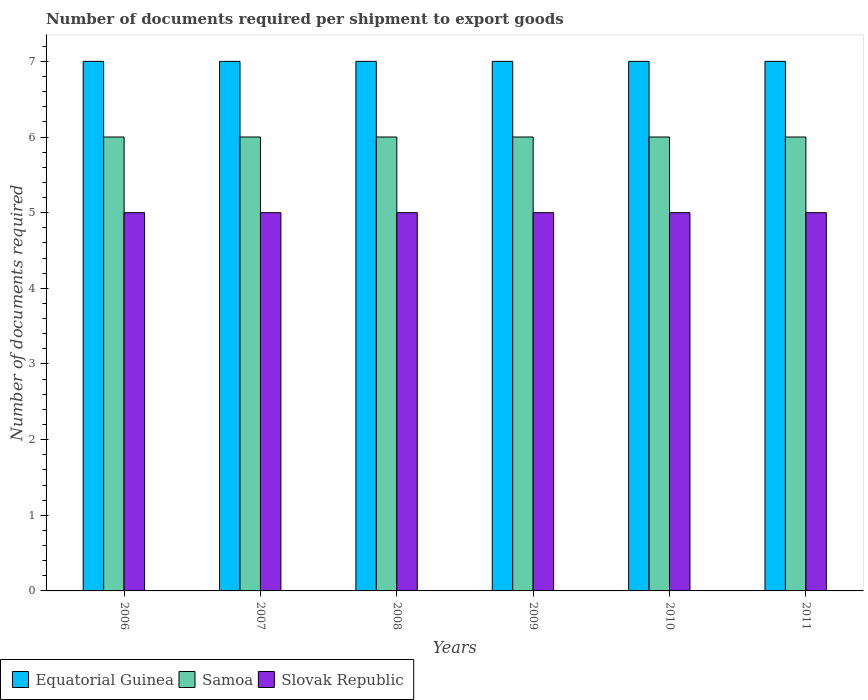How many different coloured bars are there?
Give a very brief answer. 3. How many groups of bars are there?
Your answer should be compact. 6. How many bars are there on the 1st tick from the left?
Offer a terse response. 3. What is the label of the 1st group of bars from the left?
Give a very brief answer. 2006. What is the number of documents required per shipment to export goods in Equatorial Guinea in 2011?
Provide a succinct answer. 7. Across all years, what is the maximum number of documents required per shipment to export goods in Slovak Republic?
Keep it short and to the point. 5. Across all years, what is the minimum number of documents required per shipment to export goods in Slovak Republic?
Your answer should be very brief. 5. In which year was the number of documents required per shipment to export goods in Equatorial Guinea maximum?
Give a very brief answer. 2006. In which year was the number of documents required per shipment to export goods in Equatorial Guinea minimum?
Provide a short and direct response. 2006. What is the total number of documents required per shipment to export goods in Slovak Republic in the graph?
Provide a short and direct response. 30. What is the difference between the number of documents required per shipment to export goods in Samoa in 2007 and that in 2011?
Your answer should be very brief. 0. What is the difference between the number of documents required per shipment to export goods in Samoa in 2011 and the number of documents required per shipment to export goods in Slovak Republic in 2009?
Provide a short and direct response. 1. In the year 2009, what is the difference between the number of documents required per shipment to export goods in Equatorial Guinea and number of documents required per shipment to export goods in Samoa?
Your response must be concise. 1. In how many years, is the number of documents required per shipment to export goods in Equatorial Guinea greater than 1.6?
Ensure brevity in your answer.  6. What is the ratio of the number of documents required per shipment to export goods in Equatorial Guinea in 2007 to that in 2008?
Ensure brevity in your answer.  1. Is the difference between the number of documents required per shipment to export goods in Equatorial Guinea in 2006 and 2007 greater than the difference between the number of documents required per shipment to export goods in Samoa in 2006 and 2007?
Provide a short and direct response. No. In how many years, is the number of documents required per shipment to export goods in Samoa greater than the average number of documents required per shipment to export goods in Samoa taken over all years?
Your answer should be compact. 0. Is the sum of the number of documents required per shipment to export goods in Equatorial Guinea in 2006 and 2011 greater than the maximum number of documents required per shipment to export goods in Slovak Republic across all years?
Keep it short and to the point. Yes. What does the 2nd bar from the left in 2008 represents?
Your answer should be very brief. Samoa. What does the 2nd bar from the right in 2007 represents?
Give a very brief answer. Samoa. Is it the case that in every year, the sum of the number of documents required per shipment to export goods in Equatorial Guinea and number of documents required per shipment to export goods in Slovak Republic is greater than the number of documents required per shipment to export goods in Samoa?
Your response must be concise. Yes. Are all the bars in the graph horizontal?
Your answer should be very brief. No. How many years are there in the graph?
Provide a succinct answer. 6. Are the values on the major ticks of Y-axis written in scientific E-notation?
Ensure brevity in your answer.  No. Does the graph contain grids?
Provide a short and direct response. No. What is the title of the graph?
Offer a terse response. Number of documents required per shipment to export goods. Does "Least developed countries" appear as one of the legend labels in the graph?
Make the answer very short. No. What is the label or title of the Y-axis?
Keep it short and to the point. Number of documents required. What is the Number of documents required of Samoa in 2006?
Your answer should be very brief. 6. What is the Number of documents required in Slovak Republic in 2006?
Give a very brief answer. 5. What is the Number of documents required of Samoa in 2007?
Ensure brevity in your answer.  6. What is the Number of documents required of Slovak Republic in 2007?
Provide a short and direct response. 5. What is the Number of documents required in Slovak Republic in 2008?
Ensure brevity in your answer.  5. What is the Number of documents required of Equatorial Guinea in 2009?
Give a very brief answer. 7. What is the Number of documents required of Samoa in 2009?
Offer a very short reply. 6. What is the Number of documents required in Slovak Republic in 2009?
Offer a terse response. 5. What is the Number of documents required of Equatorial Guinea in 2010?
Give a very brief answer. 7. What is the Number of documents required in Samoa in 2010?
Offer a terse response. 6. What is the Number of documents required of Slovak Republic in 2010?
Provide a succinct answer. 5. What is the Number of documents required of Equatorial Guinea in 2011?
Provide a short and direct response. 7. What is the Number of documents required in Samoa in 2011?
Offer a terse response. 6. What is the Number of documents required of Slovak Republic in 2011?
Make the answer very short. 5. Across all years, what is the minimum Number of documents required of Equatorial Guinea?
Your answer should be very brief. 7. Across all years, what is the minimum Number of documents required of Samoa?
Offer a terse response. 6. What is the difference between the Number of documents required of Slovak Republic in 2006 and that in 2007?
Your answer should be compact. 0. What is the difference between the Number of documents required in Slovak Republic in 2006 and that in 2008?
Keep it short and to the point. 0. What is the difference between the Number of documents required of Samoa in 2006 and that in 2009?
Ensure brevity in your answer.  0. What is the difference between the Number of documents required of Equatorial Guinea in 2006 and that in 2010?
Make the answer very short. 0. What is the difference between the Number of documents required of Samoa in 2006 and that in 2010?
Ensure brevity in your answer.  0. What is the difference between the Number of documents required in Samoa in 2006 and that in 2011?
Keep it short and to the point. 0. What is the difference between the Number of documents required in Equatorial Guinea in 2007 and that in 2008?
Make the answer very short. 0. What is the difference between the Number of documents required of Equatorial Guinea in 2007 and that in 2009?
Your response must be concise. 0. What is the difference between the Number of documents required in Equatorial Guinea in 2007 and that in 2010?
Provide a short and direct response. 0. What is the difference between the Number of documents required in Equatorial Guinea in 2007 and that in 2011?
Offer a terse response. 0. What is the difference between the Number of documents required in Samoa in 2007 and that in 2011?
Give a very brief answer. 0. What is the difference between the Number of documents required of Equatorial Guinea in 2008 and that in 2009?
Make the answer very short. 0. What is the difference between the Number of documents required of Slovak Republic in 2008 and that in 2009?
Provide a short and direct response. 0. What is the difference between the Number of documents required of Samoa in 2008 and that in 2010?
Make the answer very short. 0. What is the difference between the Number of documents required of Slovak Republic in 2008 and that in 2010?
Provide a succinct answer. 0. What is the difference between the Number of documents required of Slovak Republic in 2009 and that in 2010?
Provide a succinct answer. 0. What is the difference between the Number of documents required in Samoa in 2009 and that in 2011?
Provide a short and direct response. 0. What is the difference between the Number of documents required of Equatorial Guinea in 2010 and that in 2011?
Keep it short and to the point. 0. What is the difference between the Number of documents required in Samoa in 2010 and that in 2011?
Offer a very short reply. 0. What is the difference between the Number of documents required in Slovak Republic in 2010 and that in 2011?
Offer a terse response. 0. What is the difference between the Number of documents required in Equatorial Guinea in 2006 and the Number of documents required in Samoa in 2007?
Make the answer very short. 1. What is the difference between the Number of documents required of Equatorial Guinea in 2006 and the Number of documents required of Slovak Republic in 2007?
Provide a short and direct response. 2. What is the difference between the Number of documents required of Samoa in 2006 and the Number of documents required of Slovak Republic in 2007?
Your answer should be compact. 1. What is the difference between the Number of documents required of Equatorial Guinea in 2006 and the Number of documents required of Samoa in 2008?
Your answer should be compact. 1. What is the difference between the Number of documents required of Equatorial Guinea in 2006 and the Number of documents required of Slovak Republic in 2008?
Provide a short and direct response. 2. What is the difference between the Number of documents required in Samoa in 2006 and the Number of documents required in Slovak Republic in 2009?
Offer a very short reply. 1. What is the difference between the Number of documents required in Equatorial Guinea in 2006 and the Number of documents required in Slovak Republic in 2010?
Give a very brief answer. 2. What is the difference between the Number of documents required in Samoa in 2006 and the Number of documents required in Slovak Republic in 2010?
Make the answer very short. 1. What is the difference between the Number of documents required of Equatorial Guinea in 2006 and the Number of documents required of Slovak Republic in 2011?
Provide a succinct answer. 2. What is the difference between the Number of documents required in Equatorial Guinea in 2007 and the Number of documents required in Slovak Republic in 2008?
Give a very brief answer. 2. What is the difference between the Number of documents required in Samoa in 2007 and the Number of documents required in Slovak Republic in 2009?
Your answer should be very brief. 1. What is the difference between the Number of documents required in Equatorial Guinea in 2007 and the Number of documents required in Samoa in 2010?
Offer a terse response. 1. What is the difference between the Number of documents required of Samoa in 2007 and the Number of documents required of Slovak Republic in 2010?
Give a very brief answer. 1. What is the difference between the Number of documents required in Equatorial Guinea in 2007 and the Number of documents required in Samoa in 2011?
Ensure brevity in your answer.  1. What is the difference between the Number of documents required in Equatorial Guinea in 2007 and the Number of documents required in Slovak Republic in 2011?
Keep it short and to the point. 2. What is the difference between the Number of documents required in Samoa in 2007 and the Number of documents required in Slovak Republic in 2011?
Your response must be concise. 1. What is the difference between the Number of documents required of Equatorial Guinea in 2008 and the Number of documents required of Samoa in 2009?
Your answer should be compact. 1. What is the difference between the Number of documents required of Equatorial Guinea in 2008 and the Number of documents required of Slovak Republic in 2009?
Your answer should be very brief. 2. What is the difference between the Number of documents required of Samoa in 2008 and the Number of documents required of Slovak Republic in 2009?
Your answer should be very brief. 1. What is the difference between the Number of documents required in Samoa in 2008 and the Number of documents required in Slovak Republic in 2010?
Keep it short and to the point. 1. What is the difference between the Number of documents required in Equatorial Guinea in 2008 and the Number of documents required in Samoa in 2011?
Provide a succinct answer. 1. What is the difference between the Number of documents required in Equatorial Guinea in 2008 and the Number of documents required in Slovak Republic in 2011?
Keep it short and to the point. 2. What is the difference between the Number of documents required of Equatorial Guinea in 2009 and the Number of documents required of Samoa in 2010?
Make the answer very short. 1. What is the difference between the Number of documents required in Equatorial Guinea in 2009 and the Number of documents required in Slovak Republic in 2010?
Provide a short and direct response. 2. What is the difference between the Number of documents required of Samoa in 2009 and the Number of documents required of Slovak Republic in 2010?
Your answer should be compact. 1. What is the difference between the Number of documents required of Equatorial Guinea in 2009 and the Number of documents required of Samoa in 2011?
Make the answer very short. 1. What is the difference between the Number of documents required in Samoa in 2009 and the Number of documents required in Slovak Republic in 2011?
Offer a terse response. 1. What is the difference between the Number of documents required of Equatorial Guinea in 2010 and the Number of documents required of Samoa in 2011?
Your answer should be very brief. 1. What is the average Number of documents required in Samoa per year?
Offer a terse response. 6. In the year 2006, what is the difference between the Number of documents required in Equatorial Guinea and Number of documents required in Samoa?
Make the answer very short. 1. In the year 2007, what is the difference between the Number of documents required of Equatorial Guinea and Number of documents required of Samoa?
Ensure brevity in your answer.  1. In the year 2007, what is the difference between the Number of documents required of Samoa and Number of documents required of Slovak Republic?
Keep it short and to the point. 1. In the year 2009, what is the difference between the Number of documents required in Equatorial Guinea and Number of documents required in Slovak Republic?
Offer a terse response. 2. In the year 2009, what is the difference between the Number of documents required of Samoa and Number of documents required of Slovak Republic?
Offer a very short reply. 1. In the year 2010, what is the difference between the Number of documents required in Equatorial Guinea and Number of documents required in Samoa?
Provide a succinct answer. 1. In the year 2010, what is the difference between the Number of documents required in Samoa and Number of documents required in Slovak Republic?
Give a very brief answer. 1. In the year 2011, what is the difference between the Number of documents required of Equatorial Guinea and Number of documents required of Samoa?
Provide a short and direct response. 1. In the year 2011, what is the difference between the Number of documents required in Equatorial Guinea and Number of documents required in Slovak Republic?
Make the answer very short. 2. What is the ratio of the Number of documents required in Equatorial Guinea in 2006 to that in 2007?
Offer a terse response. 1. What is the ratio of the Number of documents required of Samoa in 2006 to that in 2007?
Provide a short and direct response. 1. What is the ratio of the Number of documents required of Equatorial Guinea in 2006 to that in 2008?
Your response must be concise. 1. What is the ratio of the Number of documents required in Equatorial Guinea in 2006 to that in 2009?
Provide a succinct answer. 1. What is the ratio of the Number of documents required in Samoa in 2006 to that in 2009?
Provide a short and direct response. 1. What is the ratio of the Number of documents required in Slovak Republic in 2006 to that in 2009?
Give a very brief answer. 1. What is the ratio of the Number of documents required in Equatorial Guinea in 2006 to that in 2010?
Your answer should be compact. 1. What is the ratio of the Number of documents required in Equatorial Guinea in 2006 to that in 2011?
Your response must be concise. 1. What is the ratio of the Number of documents required in Slovak Republic in 2006 to that in 2011?
Your answer should be very brief. 1. What is the ratio of the Number of documents required in Equatorial Guinea in 2007 to that in 2008?
Your response must be concise. 1. What is the ratio of the Number of documents required of Samoa in 2007 to that in 2008?
Make the answer very short. 1. What is the ratio of the Number of documents required in Samoa in 2007 to that in 2009?
Offer a terse response. 1. What is the ratio of the Number of documents required in Slovak Republic in 2007 to that in 2009?
Offer a terse response. 1. What is the ratio of the Number of documents required of Slovak Republic in 2007 to that in 2010?
Give a very brief answer. 1. What is the ratio of the Number of documents required of Samoa in 2007 to that in 2011?
Make the answer very short. 1. What is the ratio of the Number of documents required of Equatorial Guinea in 2008 to that in 2009?
Offer a terse response. 1. What is the ratio of the Number of documents required in Slovak Republic in 2008 to that in 2009?
Give a very brief answer. 1. What is the ratio of the Number of documents required of Equatorial Guinea in 2008 to that in 2010?
Make the answer very short. 1. What is the ratio of the Number of documents required of Slovak Republic in 2009 to that in 2010?
Keep it short and to the point. 1. What is the ratio of the Number of documents required in Equatorial Guinea in 2009 to that in 2011?
Your response must be concise. 1. What is the ratio of the Number of documents required in Samoa in 2009 to that in 2011?
Provide a succinct answer. 1. What is the ratio of the Number of documents required in Equatorial Guinea in 2010 to that in 2011?
Your answer should be very brief. 1. What is the ratio of the Number of documents required of Slovak Republic in 2010 to that in 2011?
Offer a very short reply. 1. What is the difference between the highest and the second highest Number of documents required in Slovak Republic?
Your response must be concise. 0. What is the difference between the highest and the lowest Number of documents required in Slovak Republic?
Your response must be concise. 0. 